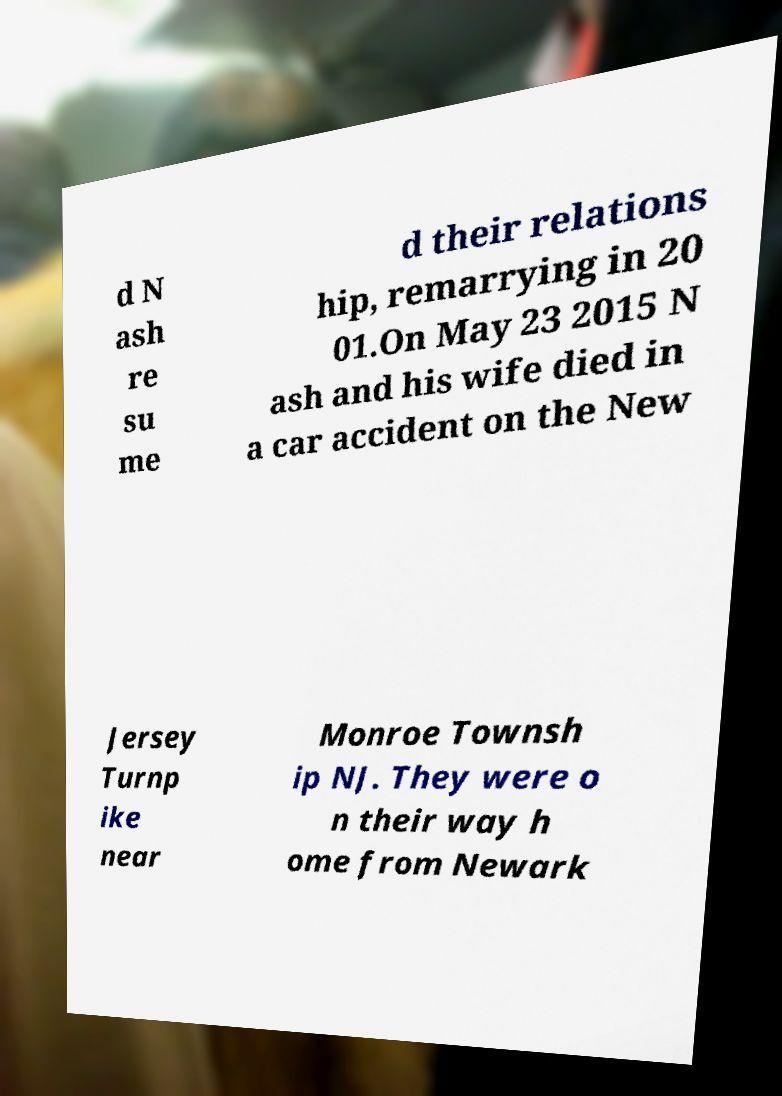Please identify and transcribe the text found in this image. d N ash re su me d their relations hip, remarrying in 20 01.On May 23 2015 N ash and his wife died in a car accident on the New Jersey Turnp ike near Monroe Townsh ip NJ. They were o n their way h ome from Newark 